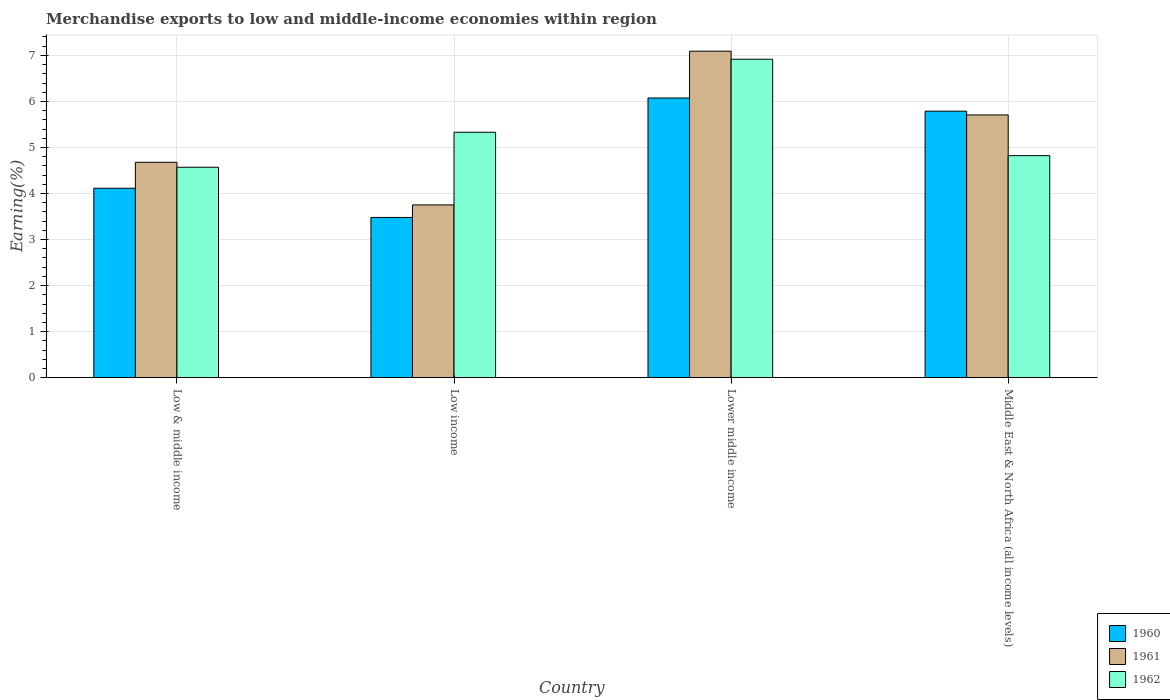How many bars are there on the 3rd tick from the left?
Keep it short and to the point. 3. What is the label of the 4th group of bars from the left?
Give a very brief answer. Middle East & North Africa (all income levels). What is the percentage of amount earned from merchandise exports in 1961 in Low income?
Offer a very short reply. 3.75. Across all countries, what is the maximum percentage of amount earned from merchandise exports in 1962?
Your answer should be compact. 6.92. Across all countries, what is the minimum percentage of amount earned from merchandise exports in 1960?
Offer a terse response. 3.48. In which country was the percentage of amount earned from merchandise exports in 1961 maximum?
Make the answer very short. Lower middle income. In which country was the percentage of amount earned from merchandise exports in 1962 minimum?
Your answer should be compact. Low & middle income. What is the total percentage of amount earned from merchandise exports in 1960 in the graph?
Make the answer very short. 19.46. What is the difference between the percentage of amount earned from merchandise exports in 1962 in Lower middle income and that in Middle East & North Africa (all income levels)?
Ensure brevity in your answer.  2.09. What is the difference between the percentage of amount earned from merchandise exports in 1961 in Low income and the percentage of amount earned from merchandise exports in 1962 in Lower middle income?
Ensure brevity in your answer.  -3.16. What is the average percentage of amount earned from merchandise exports in 1961 per country?
Your response must be concise. 5.31. What is the difference between the percentage of amount earned from merchandise exports of/in 1961 and percentage of amount earned from merchandise exports of/in 1960 in Middle East & North Africa (all income levels)?
Your response must be concise. -0.08. In how many countries, is the percentage of amount earned from merchandise exports in 1960 greater than 1 %?
Provide a short and direct response. 4. What is the ratio of the percentage of amount earned from merchandise exports in 1962 in Lower middle income to that in Middle East & North Africa (all income levels)?
Offer a very short reply. 1.43. Is the difference between the percentage of amount earned from merchandise exports in 1961 in Low income and Lower middle income greater than the difference between the percentage of amount earned from merchandise exports in 1960 in Low income and Lower middle income?
Your answer should be compact. No. What is the difference between the highest and the second highest percentage of amount earned from merchandise exports in 1962?
Your answer should be compact. -0.51. What is the difference between the highest and the lowest percentage of amount earned from merchandise exports in 1961?
Provide a succinct answer. 3.34. Is the sum of the percentage of amount earned from merchandise exports in 1961 in Low income and Middle East & North Africa (all income levels) greater than the maximum percentage of amount earned from merchandise exports in 1962 across all countries?
Your answer should be very brief. Yes. What does the 1st bar from the left in Low income represents?
Ensure brevity in your answer.  1960. What does the 2nd bar from the right in Middle East & North Africa (all income levels) represents?
Make the answer very short. 1961. Does the graph contain grids?
Ensure brevity in your answer.  Yes. Where does the legend appear in the graph?
Offer a terse response. Bottom right. How many legend labels are there?
Offer a very short reply. 3. What is the title of the graph?
Your answer should be very brief. Merchandise exports to low and middle-income economies within region. Does "1968" appear as one of the legend labels in the graph?
Your response must be concise. No. What is the label or title of the Y-axis?
Ensure brevity in your answer.  Earning(%). What is the Earning(%) of 1960 in Low & middle income?
Your response must be concise. 4.11. What is the Earning(%) of 1961 in Low & middle income?
Your answer should be compact. 4.68. What is the Earning(%) of 1962 in Low & middle income?
Provide a short and direct response. 4.57. What is the Earning(%) in 1960 in Low income?
Give a very brief answer. 3.48. What is the Earning(%) in 1961 in Low income?
Your answer should be compact. 3.75. What is the Earning(%) in 1962 in Low income?
Keep it short and to the point. 5.33. What is the Earning(%) of 1960 in Lower middle income?
Offer a terse response. 6.07. What is the Earning(%) in 1961 in Lower middle income?
Your answer should be very brief. 7.09. What is the Earning(%) of 1962 in Lower middle income?
Your response must be concise. 6.92. What is the Earning(%) in 1960 in Middle East & North Africa (all income levels)?
Make the answer very short. 5.79. What is the Earning(%) of 1961 in Middle East & North Africa (all income levels)?
Ensure brevity in your answer.  5.71. What is the Earning(%) of 1962 in Middle East & North Africa (all income levels)?
Your answer should be compact. 4.82. Across all countries, what is the maximum Earning(%) of 1960?
Your response must be concise. 6.07. Across all countries, what is the maximum Earning(%) in 1961?
Provide a short and direct response. 7.09. Across all countries, what is the maximum Earning(%) in 1962?
Keep it short and to the point. 6.92. Across all countries, what is the minimum Earning(%) of 1960?
Make the answer very short. 3.48. Across all countries, what is the minimum Earning(%) of 1961?
Provide a short and direct response. 3.75. Across all countries, what is the minimum Earning(%) in 1962?
Keep it short and to the point. 4.57. What is the total Earning(%) of 1960 in the graph?
Offer a very short reply. 19.46. What is the total Earning(%) in 1961 in the graph?
Your response must be concise. 21.23. What is the total Earning(%) of 1962 in the graph?
Ensure brevity in your answer.  21.64. What is the difference between the Earning(%) in 1960 in Low & middle income and that in Low income?
Make the answer very short. 0.63. What is the difference between the Earning(%) in 1961 in Low & middle income and that in Low income?
Offer a terse response. 0.93. What is the difference between the Earning(%) in 1962 in Low & middle income and that in Low income?
Offer a terse response. -0.76. What is the difference between the Earning(%) of 1960 in Low & middle income and that in Lower middle income?
Make the answer very short. -1.96. What is the difference between the Earning(%) of 1961 in Low & middle income and that in Lower middle income?
Offer a terse response. -2.41. What is the difference between the Earning(%) of 1962 in Low & middle income and that in Lower middle income?
Keep it short and to the point. -2.35. What is the difference between the Earning(%) in 1960 in Low & middle income and that in Middle East & North Africa (all income levels)?
Your answer should be compact. -1.67. What is the difference between the Earning(%) of 1961 in Low & middle income and that in Middle East & North Africa (all income levels)?
Keep it short and to the point. -1.03. What is the difference between the Earning(%) of 1962 in Low & middle income and that in Middle East & North Africa (all income levels)?
Ensure brevity in your answer.  -0.25. What is the difference between the Earning(%) in 1960 in Low income and that in Lower middle income?
Keep it short and to the point. -2.59. What is the difference between the Earning(%) in 1961 in Low income and that in Lower middle income?
Provide a short and direct response. -3.34. What is the difference between the Earning(%) of 1962 in Low income and that in Lower middle income?
Ensure brevity in your answer.  -1.59. What is the difference between the Earning(%) of 1960 in Low income and that in Middle East & North Africa (all income levels)?
Keep it short and to the point. -2.31. What is the difference between the Earning(%) in 1961 in Low income and that in Middle East & North Africa (all income levels)?
Provide a short and direct response. -1.95. What is the difference between the Earning(%) of 1962 in Low income and that in Middle East & North Africa (all income levels)?
Give a very brief answer. 0.51. What is the difference between the Earning(%) in 1960 in Lower middle income and that in Middle East & North Africa (all income levels)?
Your response must be concise. 0.29. What is the difference between the Earning(%) of 1961 in Lower middle income and that in Middle East & North Africa (all income levels)?
Provide a short and direct response. 1.38. What is the difference between the Earning(%) in 1962 in Lower middle income and that in Middle East & North Africa (all income levels)?
Make the answer very short. 2.09. What is the difference between the Earning(%) of 1960 in Low & middle income and the Earning(%) of 1961 in Low income?
Your response must be concise. 0.36. What is the difference between the Earning(%) of 1960 in Low & middle income and the Earning(%) of 1962 in Low income?
Offer a very short reply. -1.22. What is the difference between the Earning(%) of 1961 in Low & middle income and the Earning(%) of 1962 in Low income?
Provide a succinct answer. -0.65. What is the difference between the Earning(%) of 1960 in Low & middle income and the Earning(%) of 1961 in Lower middle income?
Give a very brief answer. -2.98. What is the difference between the Earning(%) of 1960 in Low & middle income and the Earning(%) of 1962 in Lower middle income?
Offer a very short reply. -2.8. What is the difference between the Earning(%) of 1961 in Low & middle income and the Earning(%) of 1962 in Lower middle income?
Offer a terse response. -2.24. What is the difference between the Earning(%) in 1960 in Low & middle income and the Earning(%) in 1961 in Middle East & North Africa (all income levels)?
Give a very brief answer. -1.59. What is the difference between the Earning(%) of 1960 in Low & middle income and the Earning(%) of 1962 in Middle East & North Africa (all income levels)?
Offer a terse response. -0.71. What is the difference between the Earning(%) of 1961 in Low & middle income and the Earning(%) of 1962 in Middle East & North Africa (all income levels)?
Offer a very short reply. -0.14. What is the difference between the Earning(%) in 1960 in Low income and the Earning(%) in 1961 in Lower middle income?
Make the answer very short. -3.61. What is the difference between the Earning(%) of 1960 in Low income and the Earning(%) of 1962 in Lower middle income?
Keep it short and to the point. -3.44. What is the difference between the Earning(%) of 1961 in Low income and the Earning(%) of 1962 in Lower middle income?
Your response must be concise. -3.16. What is the difference between the Earning(%) of 1960 in Low income and the Earning(%) of 1961 in Middle East & North Africa (all income levels)?
Your answer should be compact. -2.23. What is the difference between the Earning(%) in 1960 in Low income and the Earning(%) in 1962 in Middle East & North Africa (all income levels)?
Offer a very short reply. -1.34. What is the difference between the Earning(%) of 1961 in Low income and the Earning(%) of 1962 in Middle East & North Africa (all income levels)?
Keep it short and to the point. -1.07. What is the difference between the Earning(%) of 1960 in Lower middle income and the Earning(%) of 1961 in Middle East & North Africa (all income levels)?
Ensure brevity in your answer.  0.37. What is the difference between the Earning(%) of 1960 in Lower middle income and the Earning(%) of 1962 in Middle East & North Africa (all income levels)?
Offer a terse response. 1.25. What is the difference between the Earning(%) of 1961 in Lower middle income and the Earning(%) of 1962 in Middle East & North Africa (all income levels)?
Make the answer very short. 2.27. What is the average Earning(%) in 1960 per country?
Offer a very short reply. 4.86. What is the average Earning(%) in 1961 per country?
Give a very brief answer. 5.31. What is the average Earning(%) in 1962 per country?
Keep it short and to the point. 5.41. What is the difference between the Earning(%) of 1960 and Earning(%) of 1961 in Low & middle income?
Provide a short and direct response. -0.56. What is the difference between the Earning(%) of 1960 and Earning(%) of 1962 in Low & middle income?
Offer a very short reply. -0.46. What is the difference between the Earning(%) of 1961 and Earning(%) of 1962 in Low & middle income?
Your answer should be compact. 0.11. What is the difference between the Earning(%) in 1960 and Earning(%) in 1961 in Low income?
Make the answer very short. -0.27. What is the difference between the Earning(%) in 1960 and Earning(%) in 1962 in Low income?
Make the answer very short. -1.85. What is the difference between the Earning(%) of 1961 and Earning(%) of 1962 in Low income?
Offer a very short reply. -1.58. What is the difference between the Earning(%) in 1960 and Earning(%) in 1961 in Lower middle income?
Offer a very short reply. -1.02. What is the difference between the Earning(%) in 1960 and Earning(%) in 1962 in Lower middle income?
Your answer should be compact. -0.84. What is the difference between the Earning(%) in 1961 and Earning(%) in 1962 in Lower middle income?
Ensure brevity in your answer.  0.17. What is the difference between the Earning(%) of 1960 and Earning(%) of 1961 in Middle East & North Africa (all income levels)?
Offer a very short reply. 0.08. What is the difference between the Earning(%) in 1960 and Earning(%) in 1962 in Middle East & North Africa (all income levels)?
Keep it short and to the point. 0.97. What is the difference between the Earning(%) in 1961 and Earning(%) in 1962 in Middle East & North Africa (all income levels)?
Give a very brief answer. 0.88. What is the ratio of the Earning(%) in 1960 in Low & middle income to that in Low income?
Your answer should be compact. 1.18. What is the ratio of the Earning(%) of 1961 in Low & middle income to that in Low income?
Ensure brevity in your answer.  1.25. What is the ratio of the Earning(%) of 1962 in Low & middle income to that in Low income?
Your response must be concise. 0.86. What is the ratio of the Earning(%) in 1960 in Low & middle income to that in Lower middle income?
Make the answer very short. 0.68. What is the ratio of the Earning(%) of 1961 in Low & middle income to that in Lower middle income?
Offer a terse response. 0.66. What is the ratio of the Earning(%) of 1962 in Low & middle income to that in Lower middle income?
Offer a very short reply. 0.66. What is the ratio of the Earning(%) of 1960 in Low & middle income to that in Middle East & North Africa (all income levels)?
Keep it short and to the point. 0.71. What is the ratio of the Earning(%) in 1961 in Low & middle income to that in Middle East & North Africa (all income levels)?
Give a very brief answer. 0.82. What is the ratio of the Earning(%) of 1962 in Low & middle income to that in Middle East & North Africa (all income levels)?
Ensure brevity in your answer.  0.95. What is the ratio of the Earning(%) in 1960 in Low income to that in Lower middle income?
Provide a short and direct response. 0.57. What is the ratio of the Earning(%) in 1961 in Low income to that in Lower middle income?
Provide a short and direct response. 0.53. What is the ratio of the Earning(%) in 1962 in Low income to that in Lower middle income?
Make the answer very short. 0.77. What is the ratio of the Earning(%) of 1960 in Low income to that in Middle East & North Africa (all income levels)?
Offer a very short reply. 0.6. What is the ratio of the Earning(%) in 1961 in Low income to that in Middle East & North Africa (all income levels)?
Keep it short and to the point. 0.66. What is the ratio of the Earning(%) in 1962 in Low income to that in Middle East & North Africa (all income levels)?
Your answer should be very brief. 1.11. What is the ratio of the Earning(%) in 1960 in Lower middle income to that in Middle East & North Africa (all income levels)?
Keep it short and to the point. 1.05. What is the ratio of the Earning(%) in 1961 in Lower middle income to that in Middle East & North Africa (all income levels)?
Keep it short and to the point. 1.24. What is the ratio of the Earning(%) in 1962 in Lower middle income to that in Middle East & North Africa (all income levels)?
Ensure brevity in your answer.  1.43. What is the difference between the highest and the second highest Earning(%) of 1960?
Provide a short and direct response. 0.29. What is the difference between the highest and the second highest Earning(%) of 1961?
Ensure brevity in your answer.  1.38. What is the difference between the highest and the second highest Earning(%) of 1962?
Keep it short and to the point. 1.59. What is the difference between the highest and the lowest Earning(%) of 1960?
Make the answer very short. 2.59. What is the difference between the highest and the lowest Earning(%) in 1961?
Ensure brevity in your answer.  3.34. What is the difference between the highest and the lowest Earning(%) of 1962?
Your answer should be very brief. 2.35. 